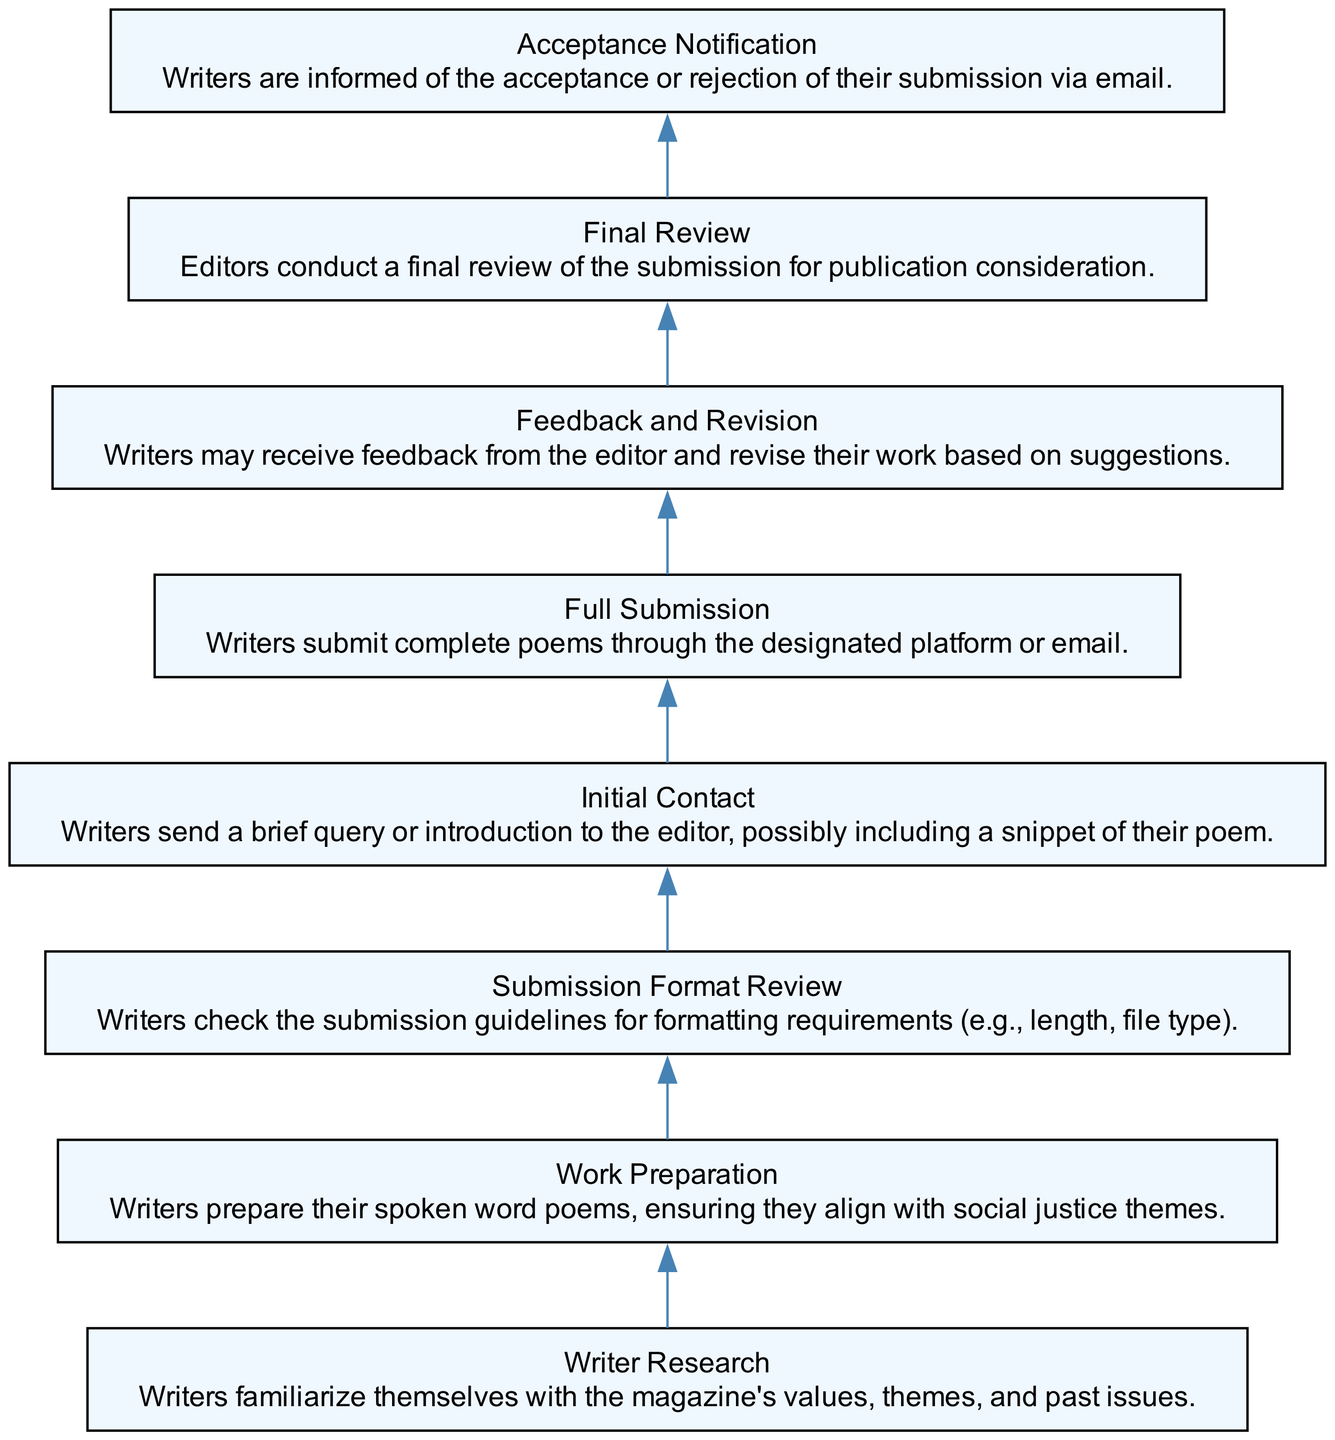What is the first step in the submission process? The diagram indicates that the first step is "Writer Research," where writers familiarize themselves with the magazine's values, themes, and past issues.
Answer: Writer Research How many steps are there in total? By counting the nodes in the diagram, I see there are eight steps listed in the submission process.
Answer: 8 What comes after "Full Submission"? Following the "Full Submission" step, the next step is "Feedback and Revision," where writers may receive feedback from the editor.
Answer: Feedback and Revision What is the last step in the process? The last step indicated in the flowchart is "Acceptance Notification," which informs writers of the acceptance or rejection of their submission.
Answer: Acceptance Notification Is "Initial Contact" before or after "Work Preparation"? "Initial Contact" occurs after "Work Preparation," as indicated by the flow of the diagram which moves downwards from one step to the next.
Answer: After How many feedback opportunities are in the process? The diagram shows one feedback opportunity, which is during the "Feedback and Revision" step after the full submission.
Answer: 1 What do writers do in the "Submission Format Review" step? In this step, writers review the submission guidelines for formatting requirements such as length and file type before submitting their work.
Answer: Check the submission guidelines Which step directly leads to the "Final Review"? The step that directly leads to the "Final Review" is "Feedback and Revision," meaning that after receiving feedback, the submission is considered for final review.
Answer: Feedback and Revision Which part of the diagram emphasizes the importance of social justice? The "Work Preparation" step emphasizes social justice, as it specifies that writers should prepare poems aligning with social justice themes.
Answer: Work Preparation 